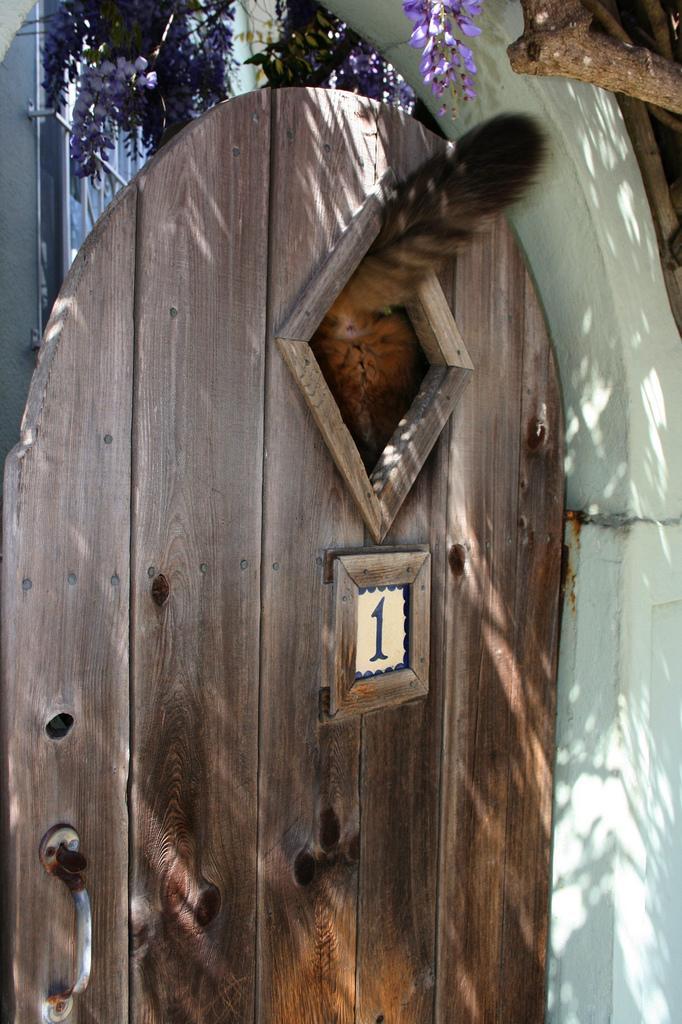Can you describe this image briefly? In this image we can see animal in a den. In the background there is a tree and building. 